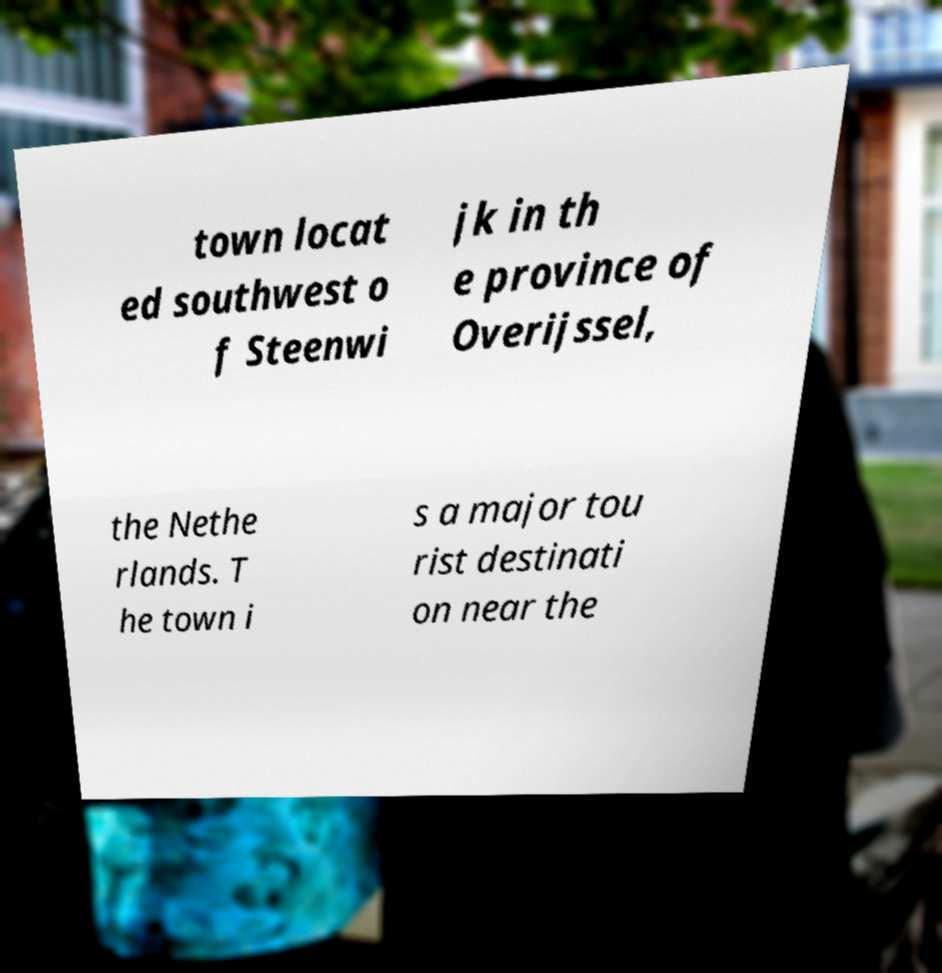Could you assist in decoding the text presented in this image and type it out clearly? town locat ed southwest o f Steenwi jk in th e province of Overijssel, the Nethe rlands. T he town i s a major tou rist destinati on near the 